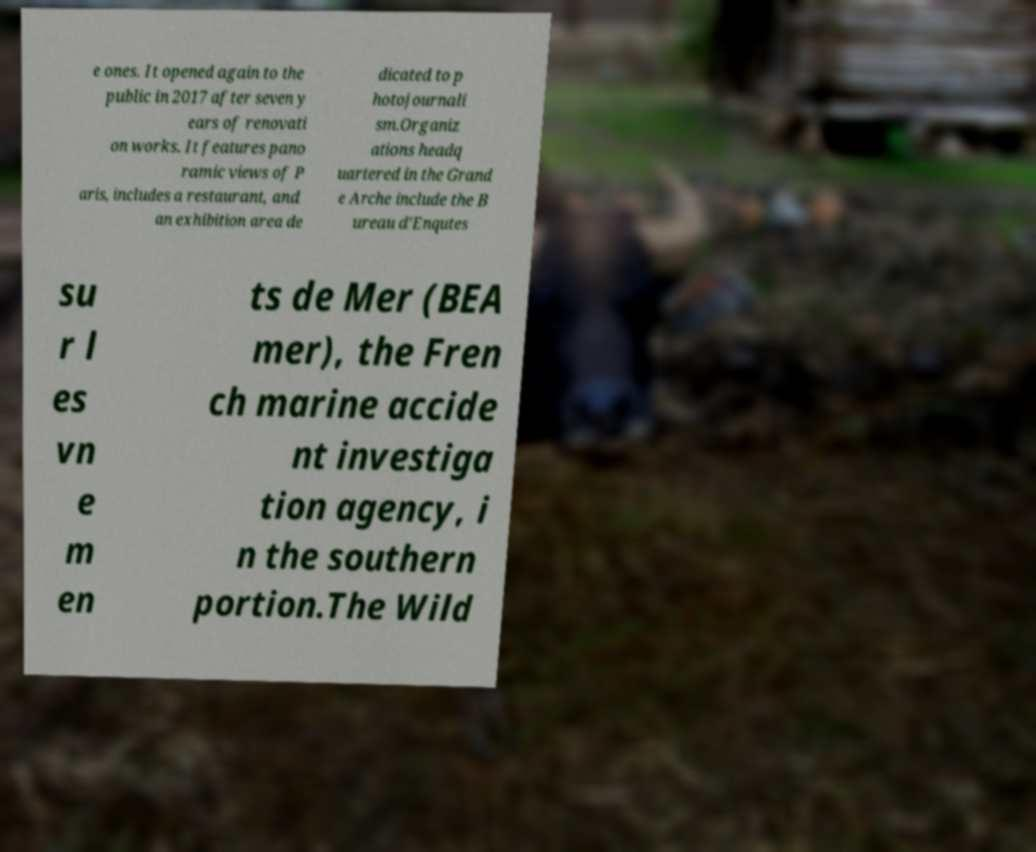Could you assist in decoding the text presented in this image and type it out clearly? e ones. It opened again to the public in 2017 after seven y ears of renovati on works. It features pano ramic views of P aris, includes a restaurant, and an exhibition area de dicated to p hotojournali sm.Organiz ations headq uartered in the Grand e Arche include the B ureau d'Enqutes su r l es vn e m en ts de Mer (BEA mer), the Fren ch marine accide nt investiga tion agency, i n the southern portion.The Wild 